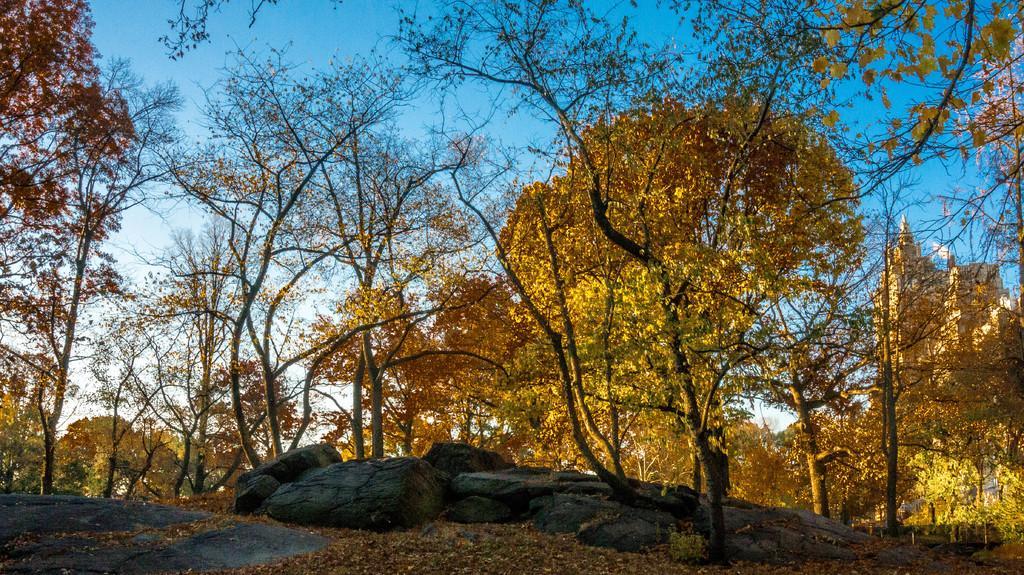In one or two sentences, can you explain what this image depicts? In this image I can see few trees and yellow color flowers. I can see few rocks. The sky is in blue and white color. 